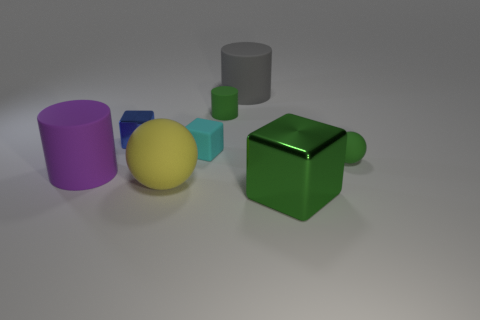How many other things are the same color as the big ball?
Provide a succinct answer. 0. What is the color of the rubber cylinder that is to the right of the small thing behind the small cube that is behind the cyan matte object?
Provide a short and direct response. Gray. Is the number of gray matte cylinders that are behind the blue shiny cube the same as the number of large yellow objects?
Your answer should be very brief. Yes. Do the object that is in front of the yellow object and the big gray matte cylinder have the same size?
Make the answer very short. Yes. How many tiny red things are there?
Your answer should be very brief. 0. How many big objects are both in front of the matte block and behind the large green block?
Offer a terse response. 2. Are there any small cyan cylinders that have the same material as the tiny ball?
Your answer should be very brief. No. The small object to the right of the small green thing that is on the left side of the green matte sphere is made of what material?
Provide a succinct answer. Rubber. Are there an equal number of purple rubber things behind the yellow sphere and tiny green matte balls on the left side of the cyan rubber block?
Offer a terse response. No. Does the gray rubber object have the same shape as the big green object?
Make the answer very short. No. 